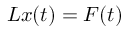<formula> <loc_0><loc_0><loc_500><loc_500>L x ( t ) = F ( t )</formula> 